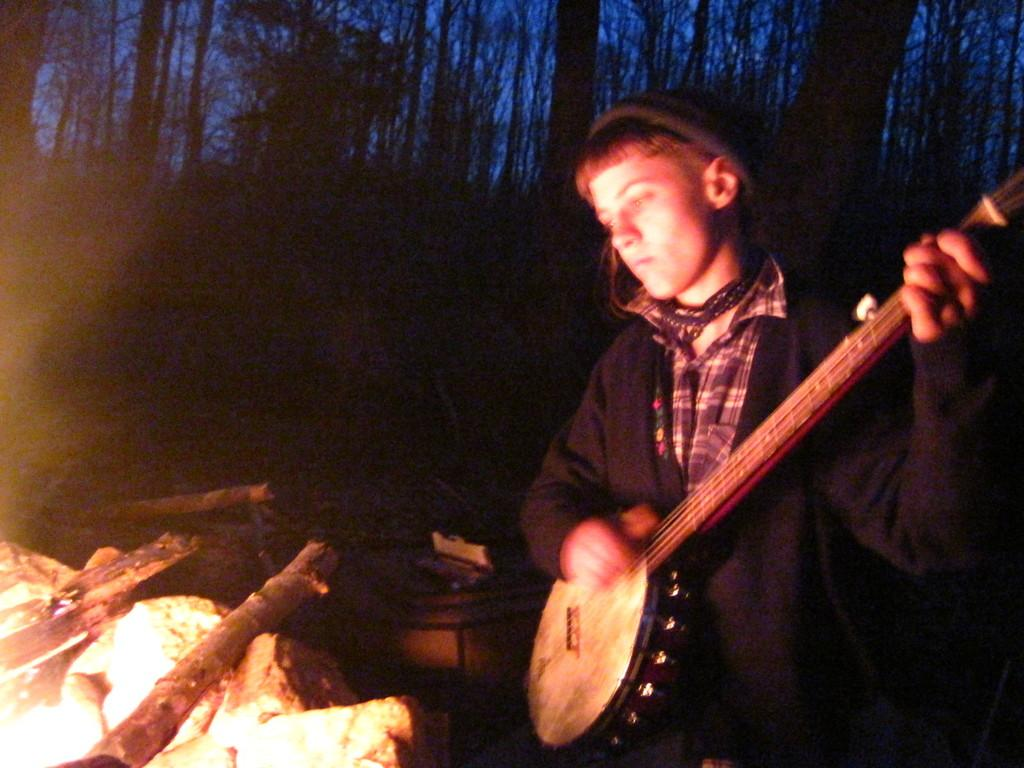What is the person in the image doing? The person is playing a banjo. What can be inferred about the location of the image? The setting appears to be a forest. What is present in front of the person? There is a fire in front of the person. What type of club is the person using to crush the rocks in the image? There are no rocks or clubs present in the image; the person is playing a banjo in a forest setting with a fire in front of them. 